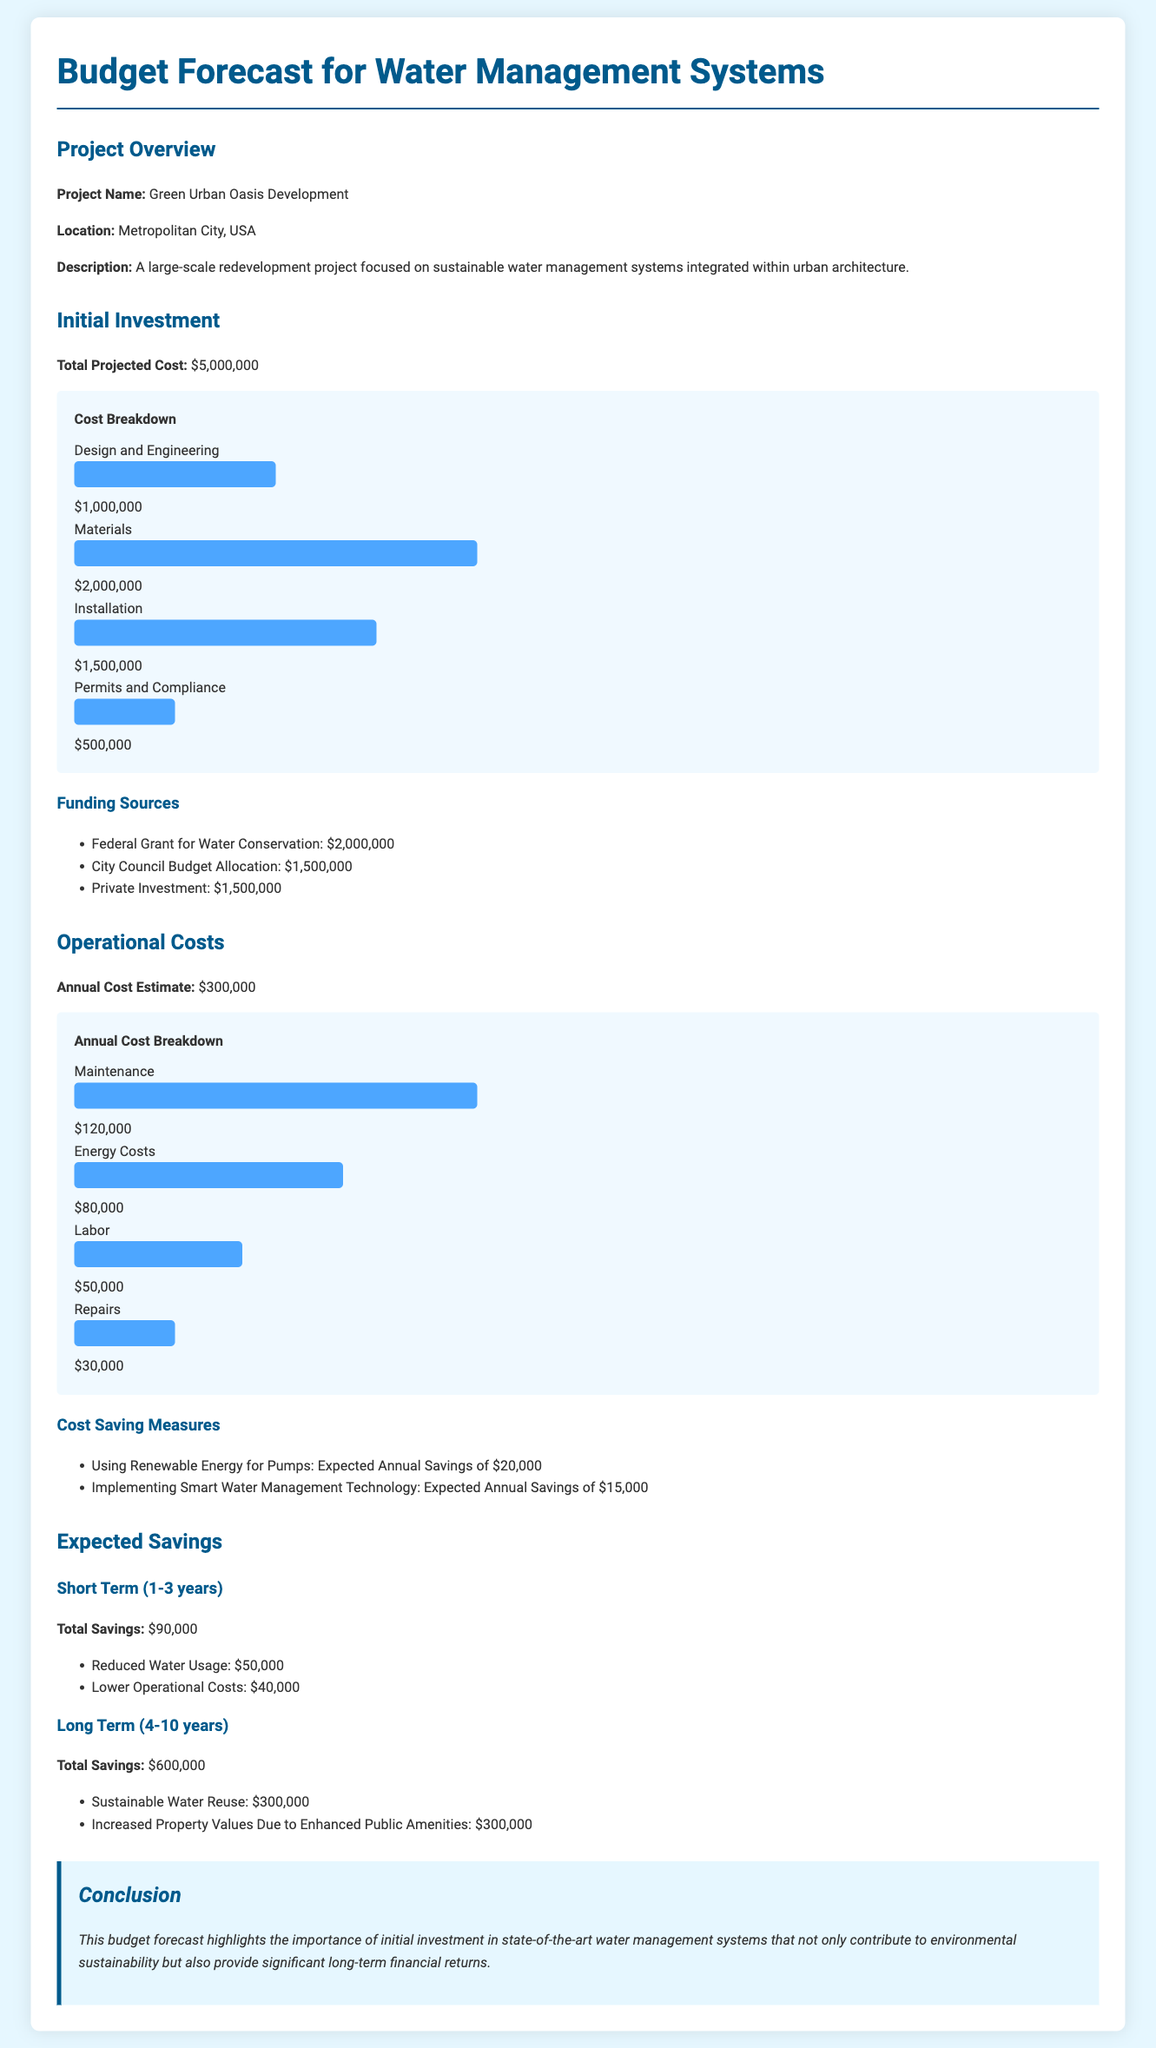What is the total projected cost? The total projected cost for the water management system is stated in the document, which is $5,000,000.
Answer: $5,000,000 How much is allocated for materials? The document specifies that the cost allocated for materials is $2,000,000.
Answer: $2,000,000 What is the annual cost estimate? The annual cost estimate provided in the document is $300,000.
Answer: $300,000 What are the expected savings in the short term? The document outlines the total expected savings in the short term as $90,000.
Answer: $90,000 How much will using renewable energy for pumps save annually? The document mentions that using renewable energy for pumps is expected to save $20,000 annually.
Answer: $20,000 What is the total expected savings in the long term? According to the document, the total expected savings in the long term is $600,000.
Answer: $600,000 How much is allocated for design and engineering? The document details the allocation for design and engineering as $1,000,000.
Answer: $1,000,000 What is the annual cost for maintenance? The document specifies that the annual cost for maintenance is $120,000.
Answer: $120,000 What project is the budget for? The budget is for the Green Urban Oasis Development project.
Answer: Green Urban Oasis Development 